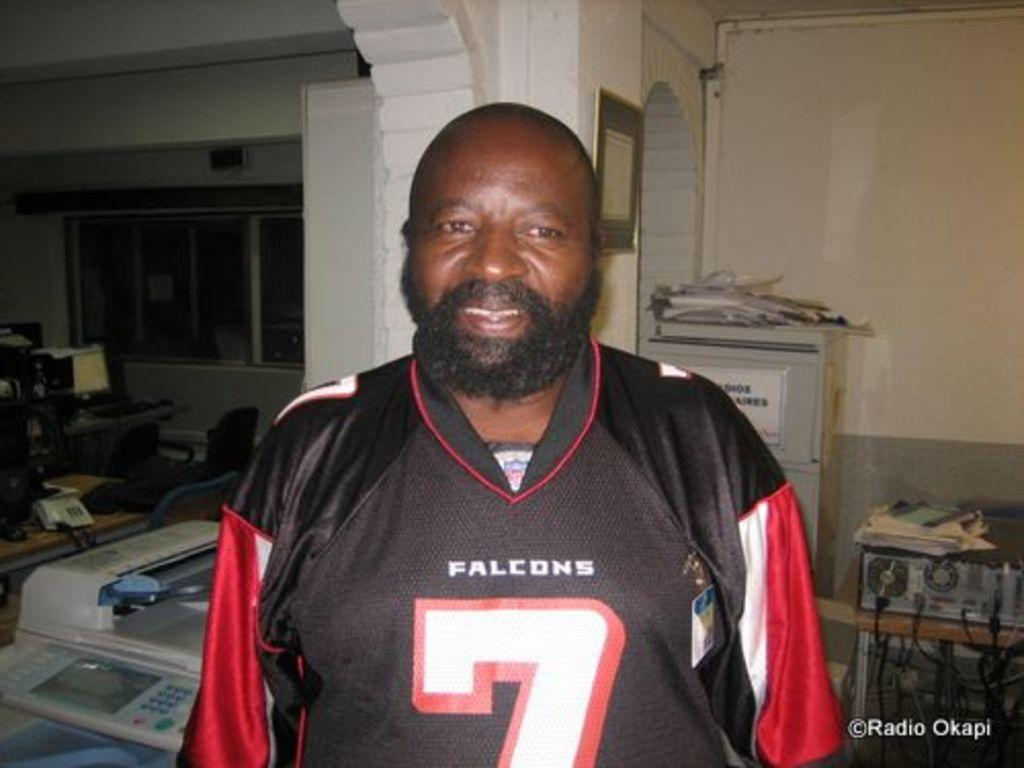<image>
Write a terse but informative summary of the picture. A man looks happy as he wears a number 7 Falcons jersey 